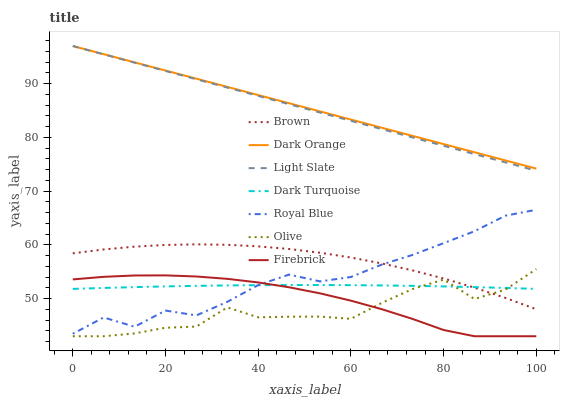Does Olive have the minimum area under the curve?
Answer yes or no. Yes. Does Dark Orange have the maximum area under the curve?
Answer yes or no. Yes. Does Light Slate have the minimum area under the curve?
Answer yes or no. No. Does Light Slate have the maximum area under the curve?
Answer yes or no. No. Is Dark Orange the smoothest?
Answer yes or no. Yes. Is Olive the roughest?
Answer yes or no. Yes. Is Light Slate the smoothest?
Answer yes or no. No. Is Light Slate the roughest?
Answer yes or no. No. Does Firebrick have the lowest value?
Answer yes or no. Yes. Does Light Slate have the lowest value?
Answer yes or no. No. Does Light Slate have the highest value?
Answer yes or no. Yes. Does Dark Turquoise have the highest value?
Answer yes or no. No. Is Olive less than Royal Blue?
Answer yes or no. Yes. Is Light Slate greater than Olive?
Answer yes or no. Yes. Does Firebrick intersect Royal Blue?
Answer yes or no. Yes. Is Firebrick less than Royal Blue?
Answer yes or no. No. Is Firebrick greater than Royal Blue?
Answer yes or no. No. Does Olive intersect Royal Blue?
Answer yes or no. No. 